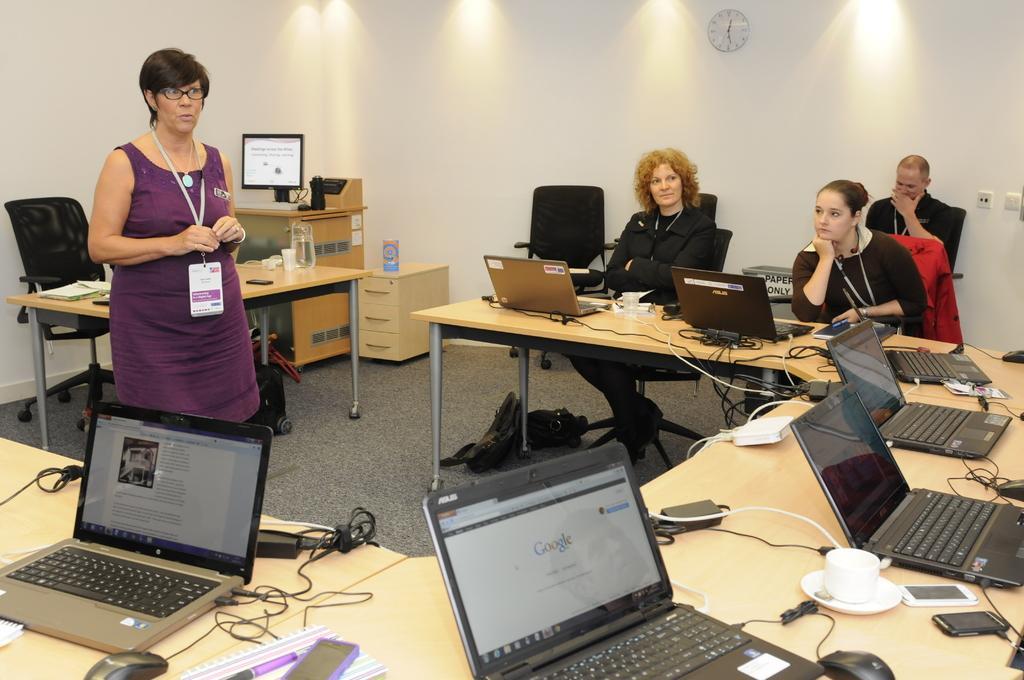Please provide a concise description of this image. It is a closed room where people are sitting and one woman is standing and she is wearing a purple dress and id card, in front of her there are tablets and laptops are placed on it and there are mobiles and one cup and saucer, at the right corner of the picture three people are sitting on the chairs behind them there is wall and a wall clock on it and on the left corner of the picture behind the person there is a table and the chair and books on it. 